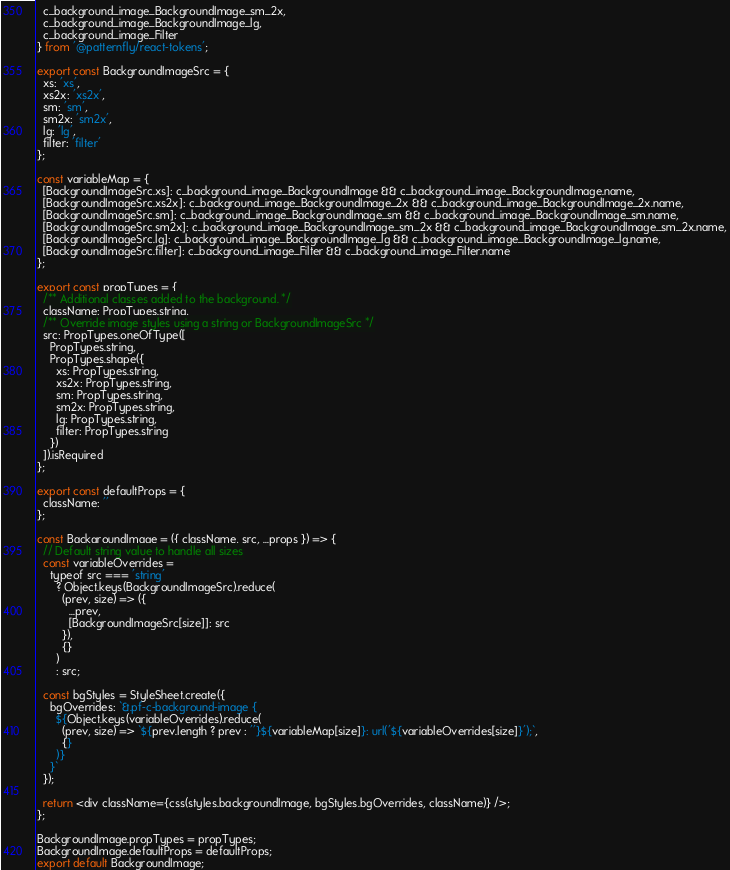Convert code to text. <code><loc_0><loc_0><loc_500><loc_500><_JavaScript_>  c_background_image_BackgroundImage_sm_2x,
  c_background_image_BackgroundImage_lg,
  c_background_image_Filter
} from '@patternfly/react-tokens';

export const BackgroundImageSrc = {
  xs: 'xs',
  xs2x: 'xs2x',
  sm: 'sm',
  sm2x: 'sm2x',
  lg: 'lg',
  filter: 'filter'
};

const variableMap = {
  [BackgroundImageSrc.xs]: c_background_image_BackgroundImage && c_background_image_BackgroundImage.name,
  [BackgroundImageSrc.xs2x]: c_background_image_BackgroundImage_2x && c_background_image_BackgroundImage_2x.name,
  [BackgroundImageSrc.sm]: c_background_image_BackgroundImage_sm && c_background_image_BackgroundImage_sm.name,
  [BackgroundImageSrc.sm2x]: c_background_image_BackgroundImage_sm_2x && c_background_image_BackgroundImage_sm_2x.name,
  [BackgroundImageSrc.lg]: c_background_image_BackgroundImage_lg && c_background_image_BackgroundImage_lg.name,
  [BackgroundImageSrc.filter]: c_background_image_Filter && c_background_image_Filter.name
};

export const propTypes = {
  /** Additional classes added to the background. */
  className: PropTypes.string,
  /** Override image styles using a string or BackgroundImageSrc */
  src: PropTypes.oneOfType([
    PropTypes.string,
    PropTypes.shape({
      xs: PropTypes.string,
      xs2x: PropTypes.string,
      sm: PropTypes.string,
      sm2x: PropTypes.string,
      lg: PropTypes.string,
      filter: PropTypes.string
    })
  ]).isRequired
};

export const defaultProps = {
  className: ''
};

const BackgroundImage = ({ className, src, ...props }) => {
  // Default string value to handle all sizes
  const variableOverrides =
    typeof src === 'string'
      ? Object.keys(BackgroundImageSrc).reduce(
        (prev, size) => ({
          ...prev,
          [BackgroundImageSrc[size]]: src
        }),
        {}
      )
      : src;

  const bgStyles = StyleSheet.create({
    bgOverrides: `&.pf-c-background-image {
      ${Object.keys(variableOverrides).reduce(
        (prev, size) => `${prev.length ? prev : ''}${variableMap[size]}: url('${variableOverrides[size]}');`,
        {}
      )}
    }`
  });

  return <div className={css(styles.backgroundImage, bgStyles.bgOverrides, className)} />;
};

BackgroundImage.propTypes = propTypes;
BackgroundImage.defaultProps = defaultProps;
export default BackgroundImage;
</code> 